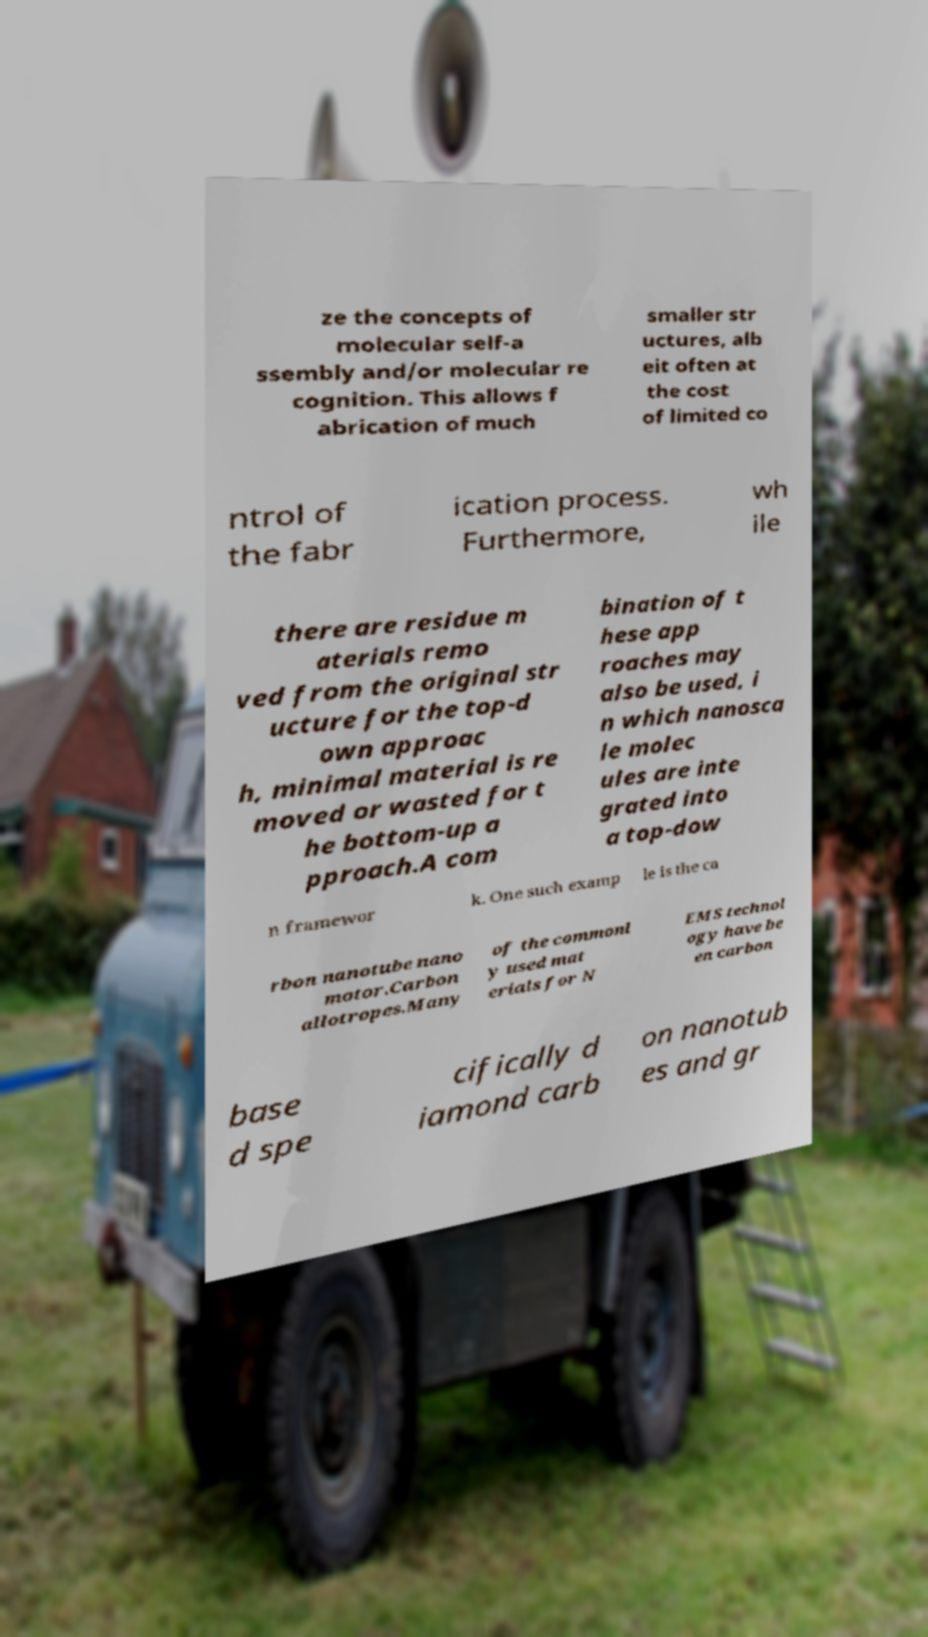Could you assist in decoding the text presented in this image and type it out clearly? ze the concepts of molecular self-a ssembly and/or molecular re cognition. This allows f abrication of much smaller str uctures, alb eit often at the cost of limited co ntrol of the fabr ication process. Furthermore, wh ile there are residue m aterials remo ved from the original str ucture for the top-d own approac h, minimal material is re moved or wasted for t he bottom-up a pproach.A com bination of t hese app roaches may also be used, i n which nanosca le molec ules are inte grated into a top-dow n framewor k. One such examp le is the ca rbon nanotube nano motor.Carbon allotropes.Many of the commonl y used mat erials for N EMS technol ogy have be en carbon base d spe cifically d iamond carb on nanotub es and gr 